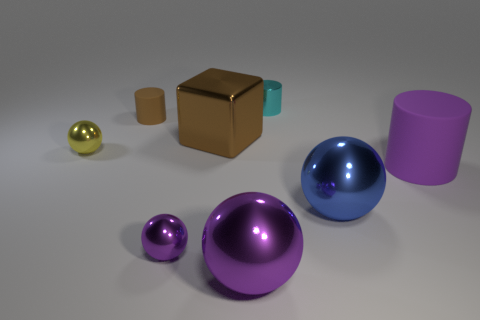What is the shape of the tiny rubber thing that is the same color as the big metallic block?
Your answer should be very brief. Cylinder. What number of other objects are the same size as the blue ball?
Offer a terse response. 3. Do the large purple thing that is right of the small cyan shiny thing and the brown object in front of the small brown matte thing have the same shape?
Provide a succinct answer. No. There is a brown shiny thing; are there any brown metal blocks right of it?
Provide a succinct answer. No. The other large thing that is the same shape as the large purple metal thing is what color?
Provide a short and direct response. Blue. Is there any other thing that is the same shape as the yellow object?
Keep it short and to the point. Yes. What is the cylinder that is to the right of the cyan object made of?
Your response must be concise. Rubber. What size is the other purple thing that is the same shape as the tiny matte thing?
Keep it short and to the point. Large. How many spheres are made of the same material as the block?
Provide a succinct answer. 4. How many tiny cylinders are the same color as the large cube?
Your response must be concise. 1. 